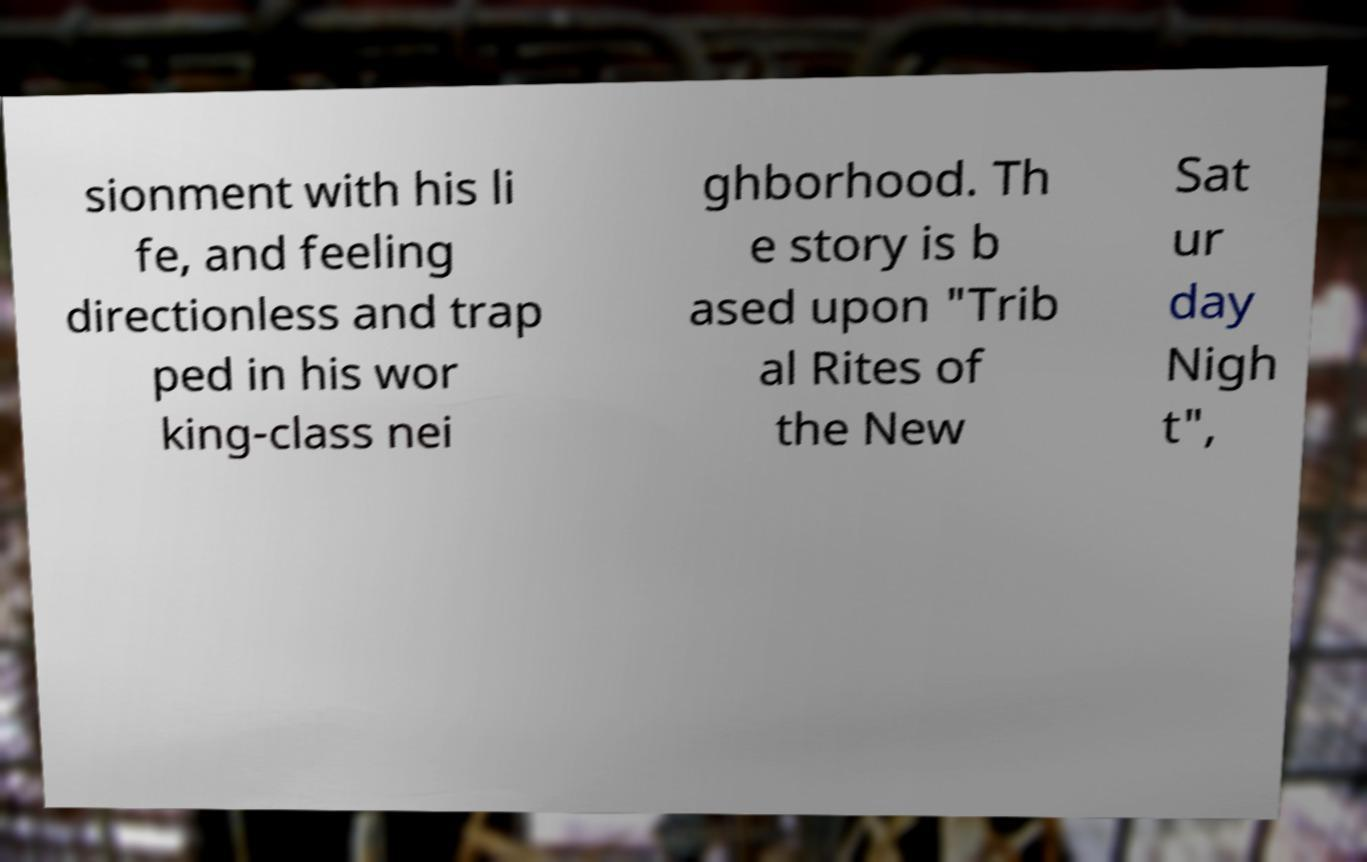Could you assist in decoding the text presented in this image and type it out clearly? sionment with his li fe, and feeling directionless and trap ped in his wor king-class nei ghborhood. Th e story is b ased upon "Trib al Rites of the New Sat ur day Nigh t", 